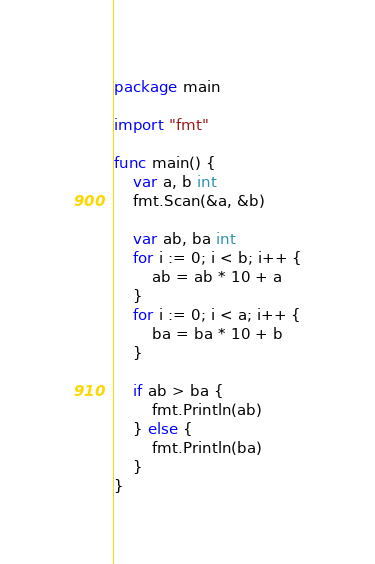Convert code to text. <code><loc_0><loc_0><loc_500><loc_500><_Go_>package main

import "fmt"

func main() {
	var a, b int
	fmt.Scan(&a, &b)

	var ab, ba int
	for i := 0; i < b; i++ {
		ab = ab * 10 + a
	}
	for i := 0; i < a; i++ {
		ba = ba * 10 + b
	}

	if ab > ba {
		fmt.Println(ab)
	} else {
		fmt.Println(ba)
	}
}
</code> 